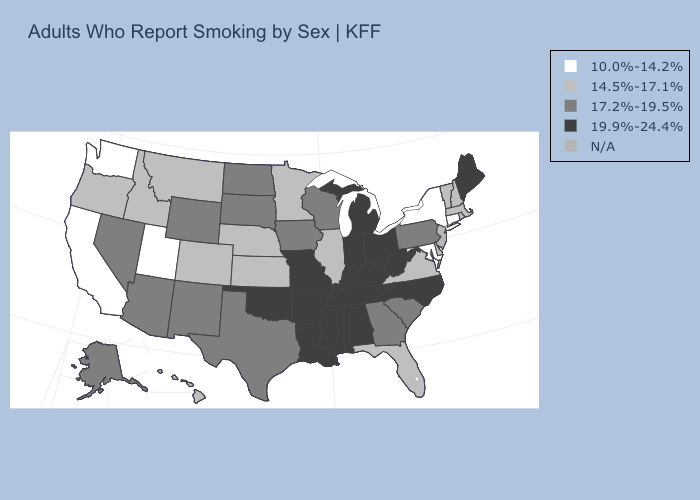Name the states that have a value in the range N/A?
Concise answer only. New Jersey. What is the value of Arkansas?
Write a very short answer. 19.9%-24.4%. Name the states that have a value in the range 19.9%-24.4%?
Short answer required. Alabama, Arkansas, Indiana, Kentucky, Louisiana, Maine, Michigan, Mississippi, Missouri, North Carolina, Ohio, Oklahoma, Tennessee, West Virginia. Among the states that border Utah , which have the highest value?
Concise answer only. Arizona, Nevada, New Mexico, Wyoming. Does Pennsylvania have the lowest value in the Northeast?
Short answer required. No. Is the legend a continuous bar?
Answer briefly. No. Does the map have missing data?
Write a very short answer. Yes. What is the lowest value in the USA?
Write a very short answer. 10.0%-14.2%. Does California have the highest value in the USA?
Quick response, please. No. What is the highest value in the USA?
Keep it brief. 19.9%-24.4%. Name the states that have a value in the range 17.2%-19.5%?
Write a very short answer. Alaska, Arizona, Georgia, Iowa, Nevada, New Mexico, North Dakota, Pennsylvania, South Carolina, South Dakota, Texas, Wisconsin, Wyoming. Name the states that have a value in the range N/A?
Write a very short answer. New Jersey. Does California have the lowest value in the West?
Answer briefly. Yes. Does Oklahoma have the highest value in the South?
Write a very short answer. Yes. 